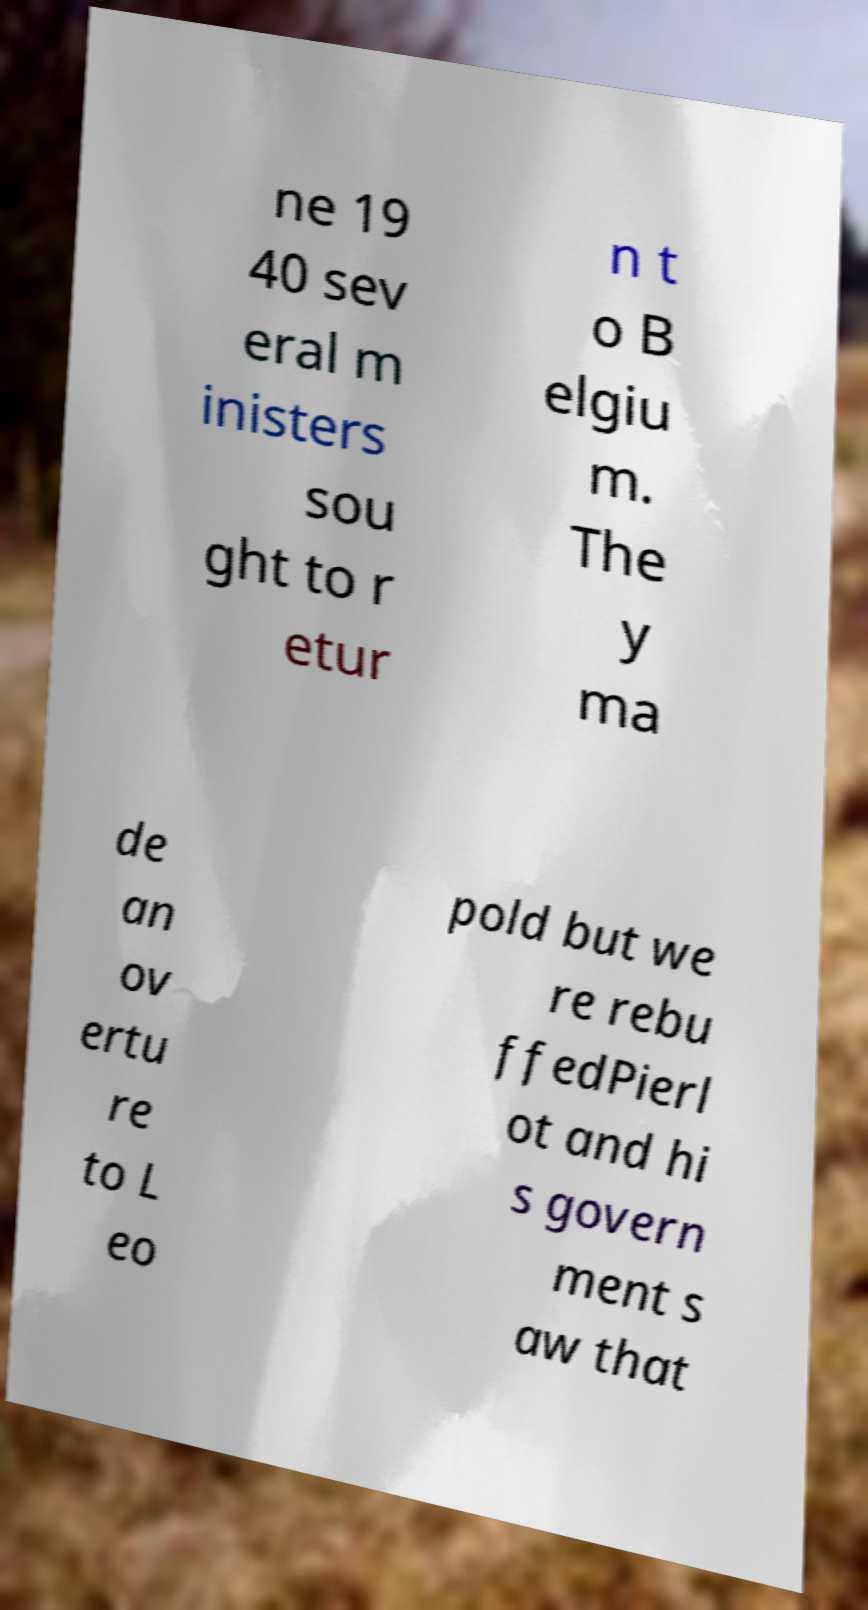For documentation purposes, I need the text within this image transcribed. Could you provide that? ne 19 40 sev eral m inisters sou ght to r etur n t o B elgiu m. The y ma de an ov ertu re to L eo pold but we re rebu ffedPierl ot and hi s govern ment s aw that 